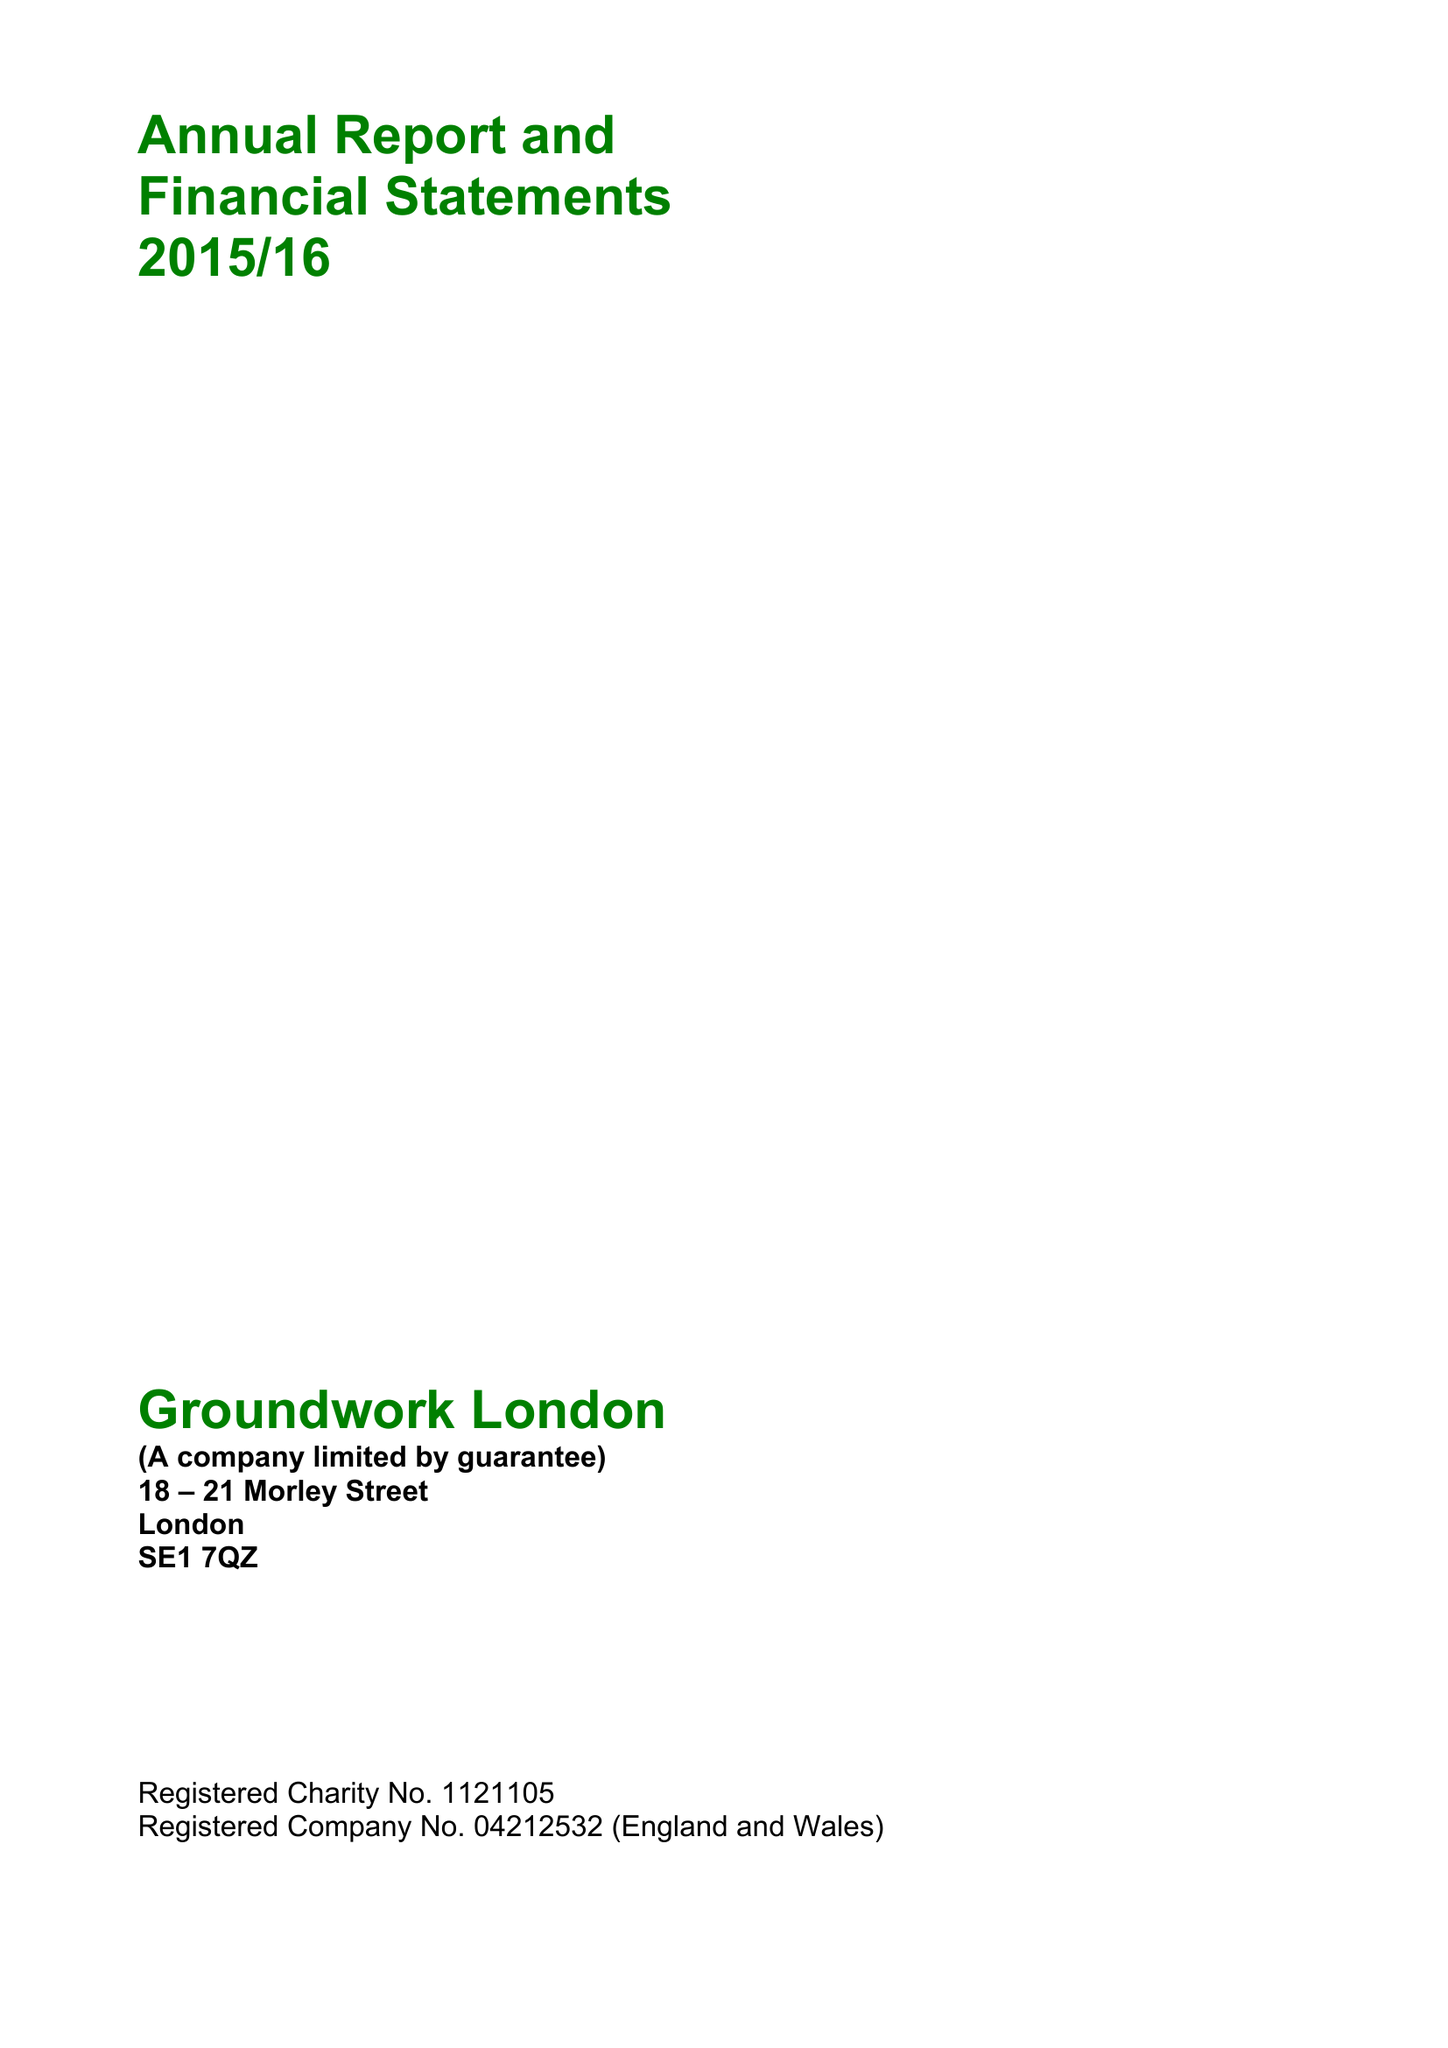What is the value for the address__post_town?
Answer the question using a single word or phrase. LONDON 